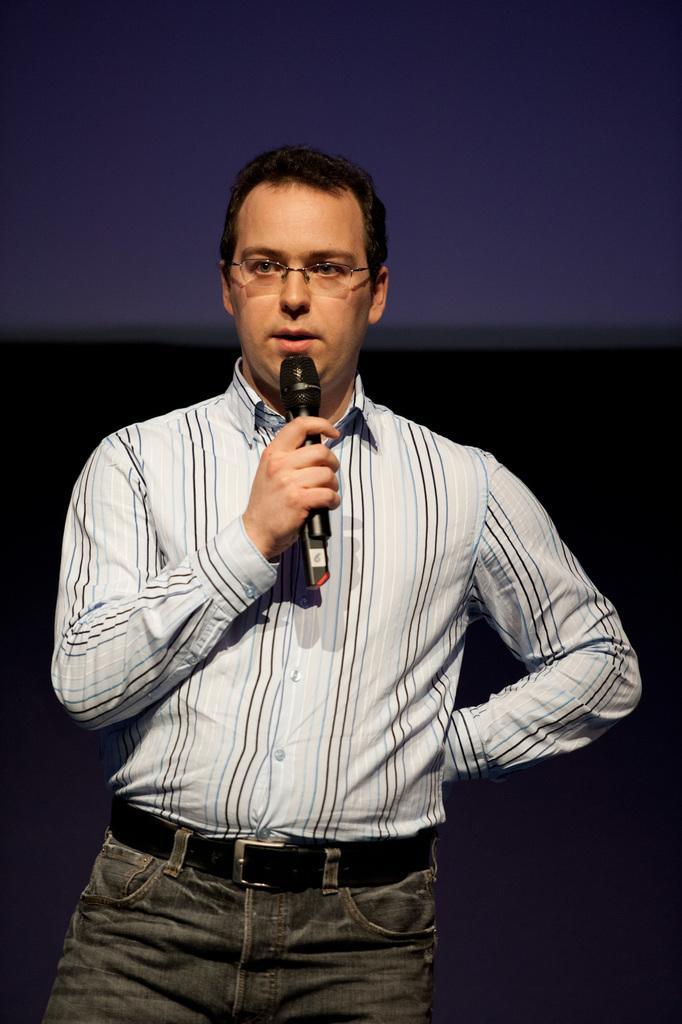Can you describe this image briefly? In this image I can see a man standing, wearing white color shirt and holding a mike in his hand. It seems like he's speaking something. The person is wearing spectacles. 